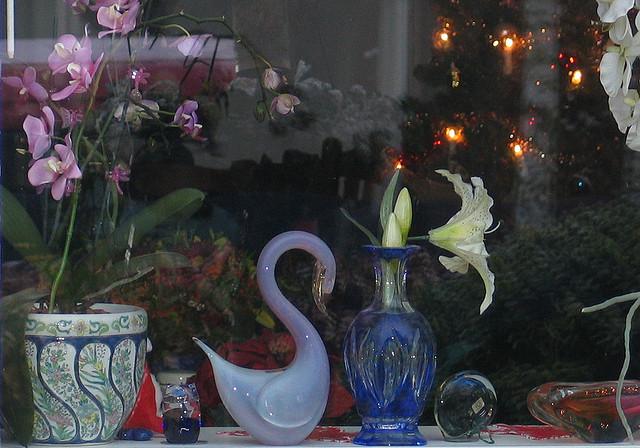What type of flower is the white one?
Short answer required. Lily. What is hanging from the vase?
Answer briefly. Flower. Can this swan break?
Write a very short answer. Yes. Where is the picture taken?
Write a very short answer. Store. 